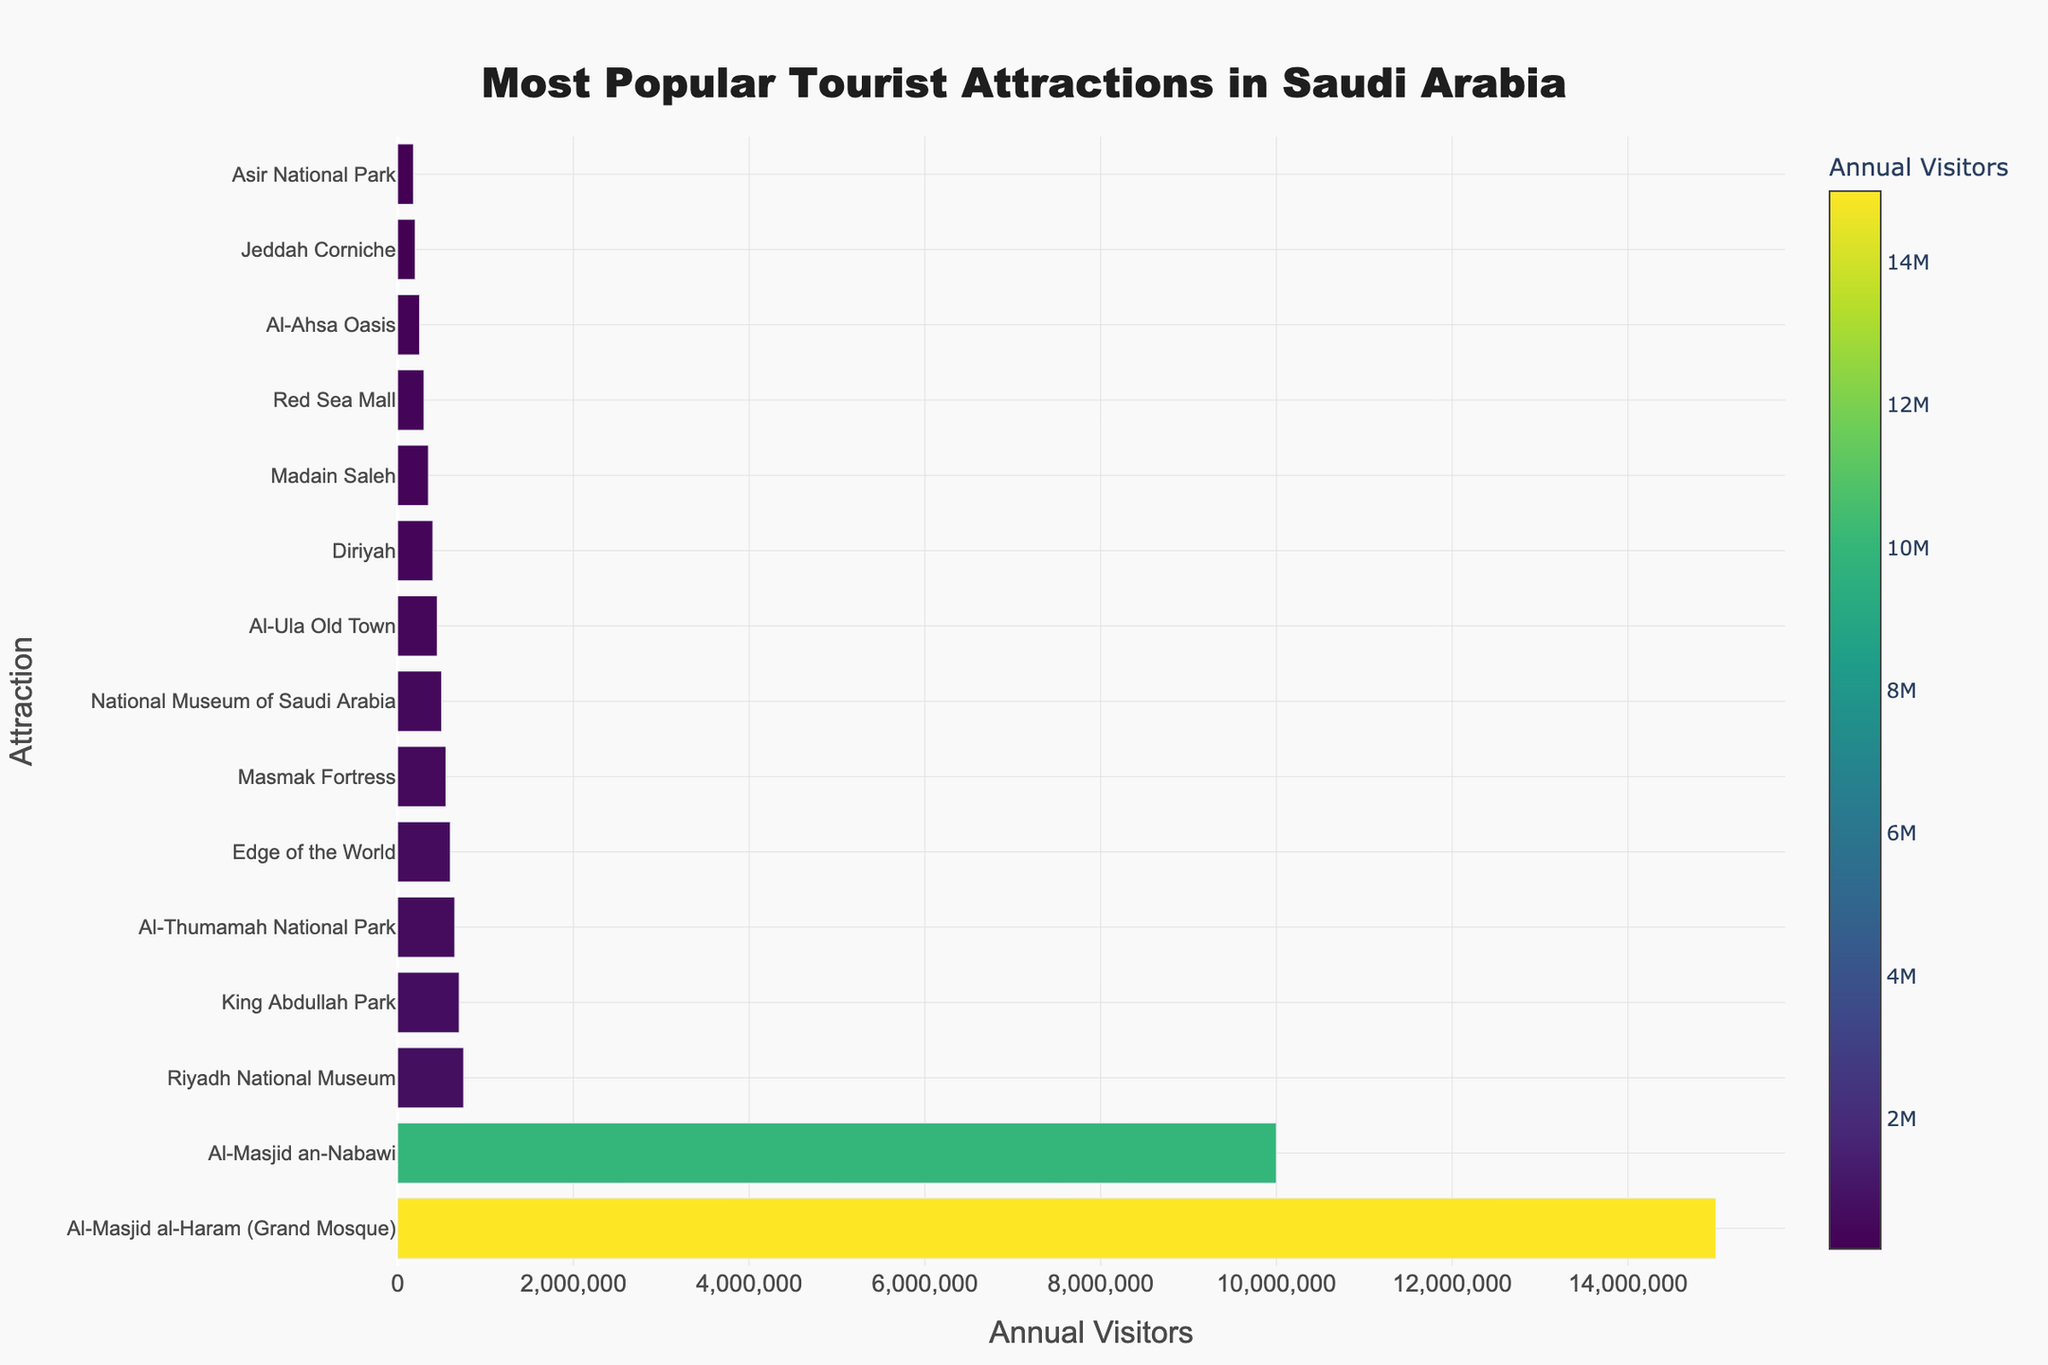Which attraction has the highest number of annual visitors? From the bar chart, the attraction with the longest bar indicates the highest number of annual visitors. Al-Masjid al-Haram (Grand Mosque) has the longest bar.
Answer: Al-Masjid al-Haram (Grand Mosque) How many more visitors does Al-Masjid al-Haram (Grand Mosque) have compared to Al-Masjid an-Nabawi? To find the difference, subtract the number of visitors of Al-Masjid an-Nabawi from Al-Masjid al-Haram (Grand Mosque): 15,000,000 - 10,000,000.
Answer: 5,000,000 What is the total number of annual visitors for the top 3 attractions combined? Sum the annual visitors of the top three attractions: Al-Masjid al-Haram (Grand Mosque), Al-Masjid an-Nabawi, and Riyadh National Museum. It will be 15,000,000 + 10,000,000 + 750,000.
Answer: 25,750,000 Which attraction has the fewest annual visitors, and how many visitors does it attract? Identify the shortest bar in the chart, indicating the attraction with the fewest visitors. In this case, it is Asir National Park.
Answer: Asir National Park, 180,000 What is the average number of annual visitors for all the attractions listed? Sum all the annual visitors and divide by the number of attractions. Calculate: (15,000,000 + 10,000,000 + 750,000 + 700,000 + 650,000 + 600,000 + 550,000 + 500,000 + 450,000 + 400,000 + 350,000 + 300,000 + 250,000 + 200,000 + 180,000) / 15.
Answer: 2,127,333 Which is more popular: Al-Thumamah National Park or Masmak Fortress? Compare the lengths of the bars representing Al-Thumamah National Park and Masmak Fortress. Al-Thumamah National Park has slightly more visitors with 650,000 compared to 550,000 for Masmak Fortress.
Answer: Al-Thumamah National Park How many attractions have annual visitors exceeding 1 million? Count the bars where the value exceeds 1 million. There are 2 bars above this threshold: Al-Masjid al-Haram (Grand Mosque) and Al-Masjid an-Nabawi.
Answer: 2 What is the difference in annual visitors between Riyadh National Museum and Al-Ula Old Town? Subtract the number of visitors for Al-Ula Old Town from Riyadh National Museum: 750,000 - 450,000.
Answer: 300,000 Which three attractions have the least number of visitors, and what are their respective visitor numbers? Identify the three attractions with the shortest bars: Asir National Park, Jeddah Corniche, and Al-Ahsa Oasis. Their visitor numbers are: 180,000, 200,000, and 250,000, respectively.
Answer: Asir National Park: 180,000, Jeddah Corniche: 200,000, Al-Ahsa Oasis: 250,000 Compare the number of visitors of Edge of the World to Red Sea Mall. Which one attracts more visitors annually? Check the lengths of the bars for Edge of the World and Red Sea Mall. Edge of the World has 600,000 visitors, while Red Sea Mall has 300,000 visitors.
Answer: Edge of the World 